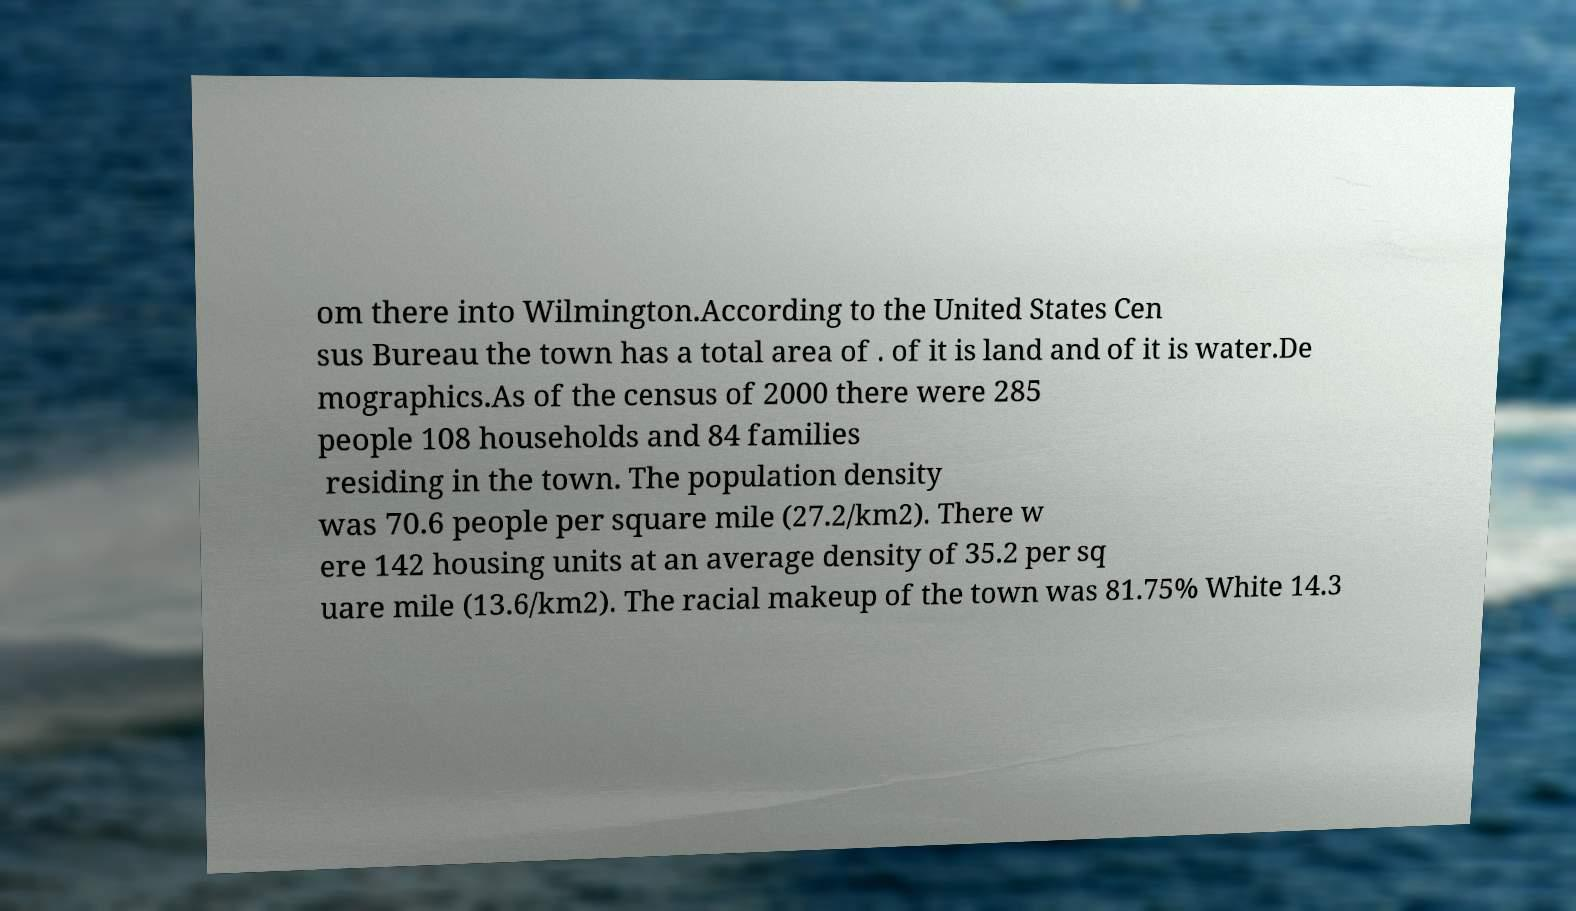There's text embedded in this image that I need extracted. Can you transcribe it verbatim? om there into Wilmington.According to the United States Cen sus Bureau the town has a total area of . of it is land and of it is water.De mographics.As of the census of 2000 there were 285 people 108 households and 84 families residing in the town. The population density was 70.6 people per square mile (27.2/km2). There w ere 142 housing units at an average density of 35.2 per sq uare mile (13.6/km2). The racial makeup of the town was 81.75% White 14.3 